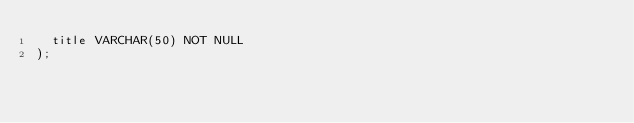<code> <loc_0><loc_0><loc_500><loc_500><_SQL_>  title VARCHAR(50) NOT NULL
);</code> 